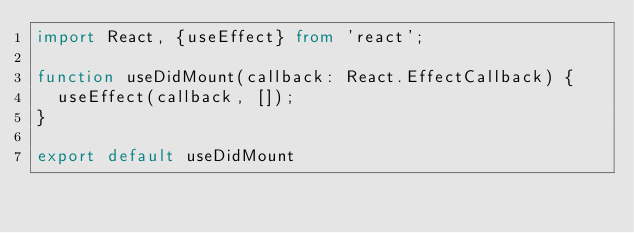<code> <loc_0><loc_0><loc_500><loc_500><_TypeScript_>import React, {useEffect} from 'react';

function useDidMount(callback: React.EffectCallback) {
  useEffect(callback, []);
}

export default useDidMount</code> 